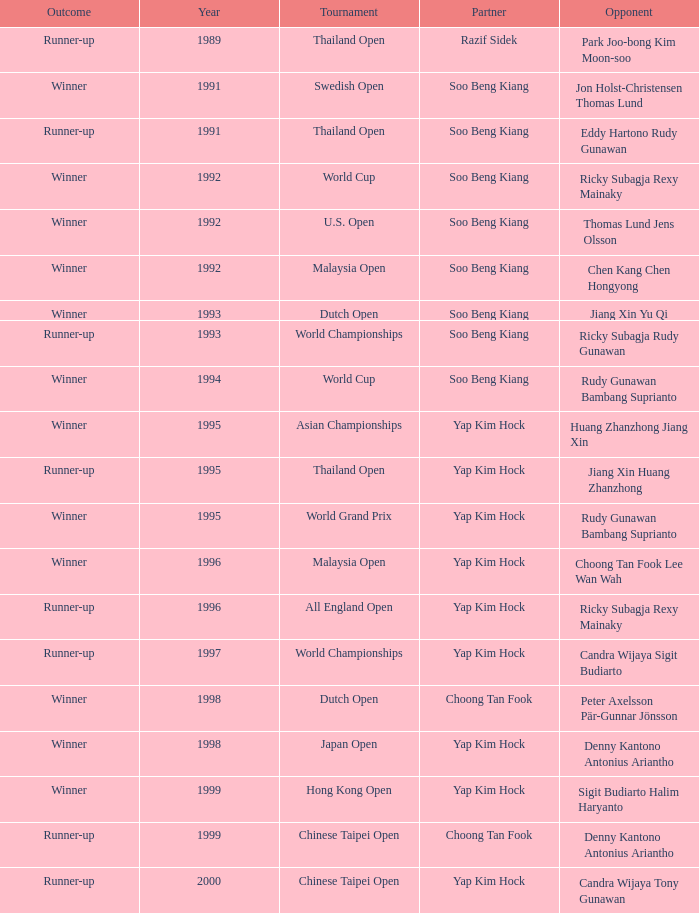Which opponent played in the Chinese Taipei Open in 2000? Candra Wijaya Tony Gunawan. 